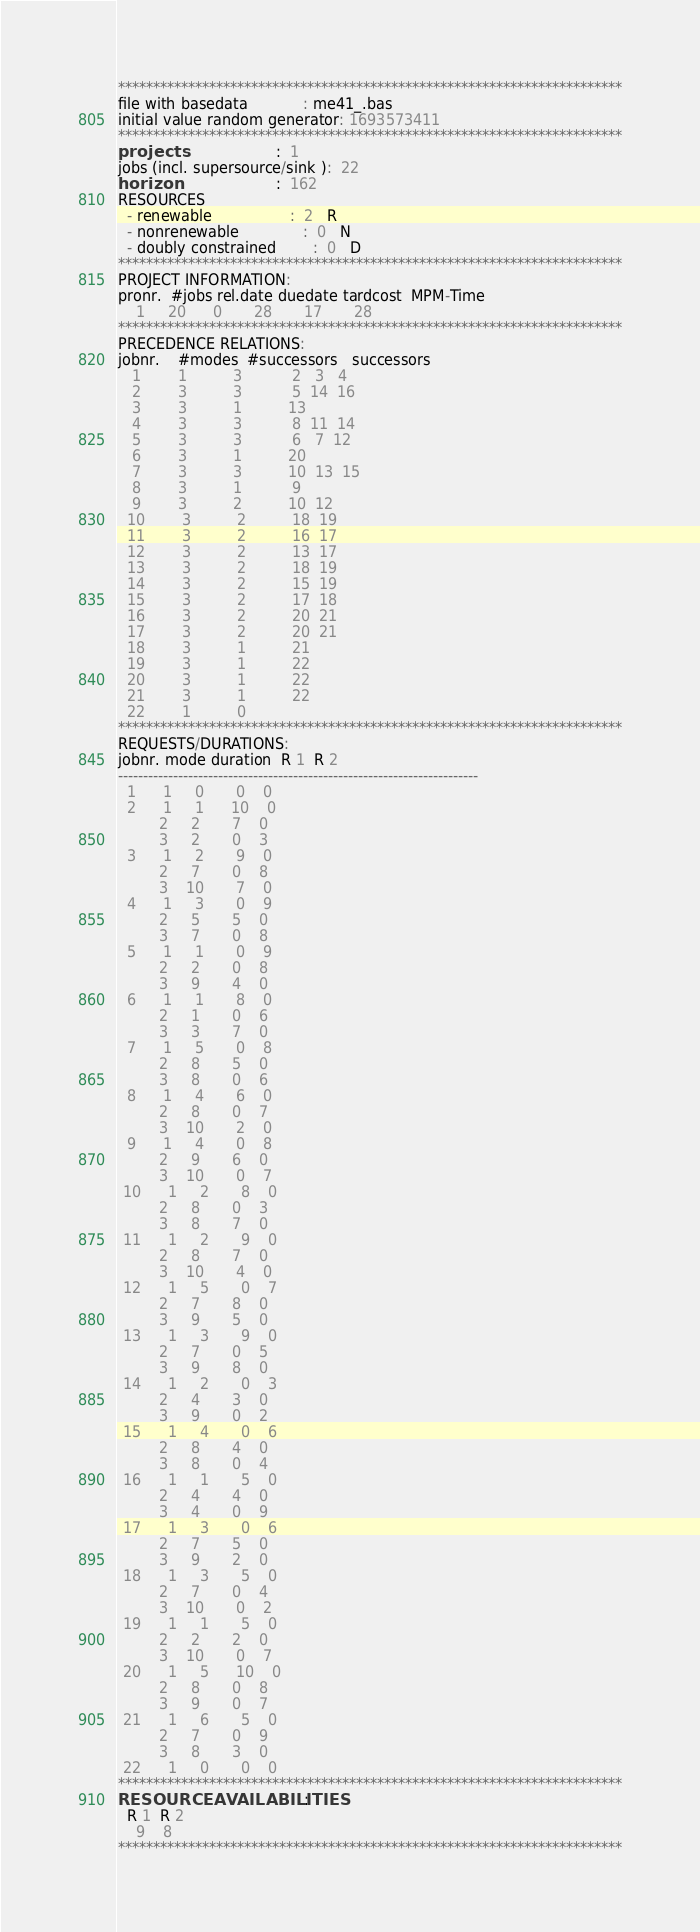Convert code to text. <code><loc_0><loc_0><loc_500><loc_500><_ObjectiveC_>************************************************************************
file with basedata            : me41_.bas
initial value random generator: 1693573411
************************************************************************
projects                      :  1
jobs (incl. supersource/sink ):  22
horizon                       :  162
RESOURCES
  - renewable                 :  2   R
  - nonrenewable              :  0   N
  - doubly constrained        :  0   D
************************************************************************
PROJECT INFORMATION:
pronr.  #jobs rel.date duedate tardcost  MPM-Time
    1     20      0       28       17       28
************************************************************************
PRECEDENCE RELATIONS:
jobnr.    #modes  #successors   successors
   1        1          3           2   3   4
   2        3          3           5  14  16
   3        3          1          13
   4        3          3           8  11  14
   5        3          3           6   7  12
   6        3          1          20
   7        3          3          10  13  15
   8        3          1           9
   9        3          2          10  12
  10        3          2          18  19
  11        3          2          16  17
  12        3          2          13  17
  13        3          2          18  19
  14        3          2          15  19
  15        3          2          17  18
  16        3          2          20  21
  17        3          2          20  21
  18        3          1          21
  19        3          1          22
  20        3          1          22
  21        3          1          22
  22        1          0        
************************************************************************
REQUESTS/DURATIONS:
jobnr. mode duration  R 1  R 2
------------------------------------------------------------------------
  1      1     0       0    0
  2      1     1      10    0
         2     2       7    0
         3     2       0    3
  3      1     2       9    0
         2     7       0    8
         3    10       7    0
  4      1     3       0    9
         2     5       5    0
         3     7       0    8
  5      1     1       0    9
         2     2       0    8
         3     9       4    0
  6      1     1       8    0
         2     1       0    6
         3     3       7    0
  7      1     5       0    8
         2     8       5    0
         3     8       0    6
  8      1     4       6    0
         2     8       0    7
         3    10       2    0
  9      1     4       0    8
         2     9       6    0
         3    10       0    7
 10      1     2       8    0
         2     8       0    3
         3     8       7    0
 11      1     2       9    0
         2     8       7    0
         3    10       4    0
 12      1     5       0    7
         2     7       8    0
         3     9       5    0
 13      1     3       9    0
         2     7       0    5
         3     9       8    0
 14      1     2       0    3
         2     4       3    0
         3     9       0    2
 15      1     4       0    6
         2     8       4    0
         3     8       0    4
 16      1     1       5    0
         2     4       4    0
         3     4       0    9
 17      1     3       0    6
         2     7       5    0
         3     9       2    0
 18      1     3       5    0
         2     7       0    4
         3    10       0    2
 19      1     1       5    0
         2     2       2    0
         3    10       0    7
 20      1     5      10    0
         2     8       0    8
         3     9       0    7
 21      1     6       5    0
         2     7       0    9
         3     8       3    0
 22      1     0       0    0
************************************************************************
RESOURCEAVAILABILITIES:
  R 1  R 2
    9    8
************************************************************************
</code> 